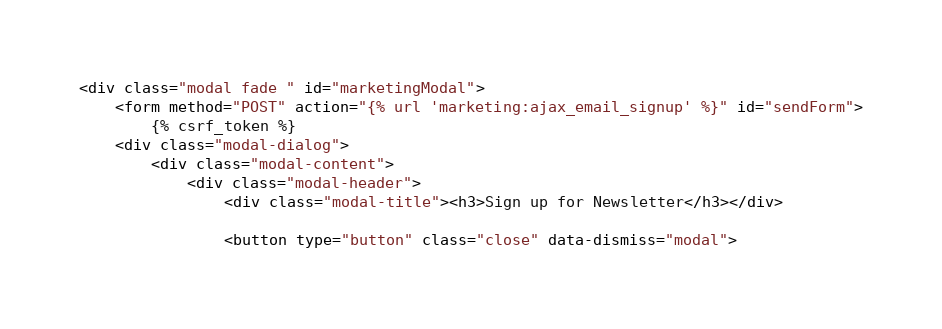Convert code to text. <code><loc_0><loc_0><loc_500><loc_500><_HTML_><div class="modal fade " id="marketingModal">
    <form method="POST" action="{% url 'marketing:ajax_email_signup' %}" id="sendForm">
        {% csrf_token %}
    <div class="modal-dialog">
        <div class="modal-content">
            <div class="modal-header">
                <div class="modal-title"><h3>Sign up for Newsletter</h3></div>

                <button type="button" class="close" data-dismiss="modal"></code> 